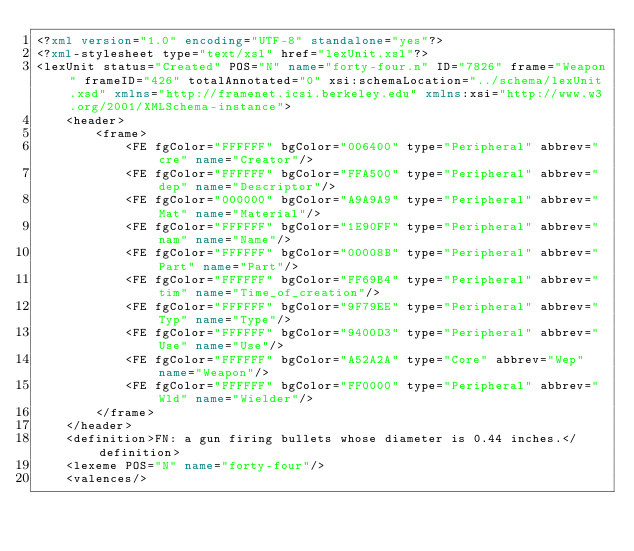<code> <loc_0><loc_0><loc_500><loc_500><_XML_><?xml version="1.0" encoding="UTF-8" standalone="yes"?>
<?xml-stylesheet type="text/xsl" href="lexUnit.xsl"?>
<lexUnit status="Created" POS="N" name="forty-four.n" ID="7826" frame="Weapon" frameID="426" totalAnnotated="0" xsi:schemaLocation="../schema/lexUnit.xsd" xmlns="http://framenet.icsi.berkeley.edu" xmlns:xsi="http://www.w3.org/2001/XMLSchema-instance">
    <header>
        <frame>
            <FE fgColor="FFFFFF" bgColor="006400" type="Peripheral" abbrev="cre" name="Creator"/>
            <FE fgColor="FFFFFF" bgColor="FFA500" type="Peripheral" abbrev="dep" name="Descriptor"/>
            <FE fgColor="000000" bgColor="A9A9A9" type="Peripheral" abbrev="Mat" name="Material"/>
            <FE fgColor="FFFFFF" bgColor="1E90FF" type="Peripheral" abbrev="nam" name="Name"/>
            <FE fgColor="FFFFFF" bgColor="00008B" type="Peripheral" abbrev="Part" name="Part"/>
            <FE fgColor="FFFFFF" bgColor="FF69B4" type="Peripheral" abbrev="tim" name="Time_of_creation"/>
            <FE fgColor="FFFFFF" bgColor="9F79EE" type="Peripheral" abbrev="Typ" name="Type"/>
            <FE fgColor="FFFFFF" bgColor="9400D3" type="Peripheral" abbrev="Use" name="Use"/>
            <FE fgColor="FFFFFF" bgColor="A52A2A" type="Core" abbrev="Wep" name="Weapon"/>
            <FE fgColor="FFFFFF" bgColor="FF0000" type="Peripheral" abbrev="Wld" name="Wielder"/>
        </frame>
    </header>
    <definition>FN: a gun firing bullets whose diameter is 0.44 inches.</definition>
    <lexeme POS="N" name="forty-four"/>
    <valences/></code> 